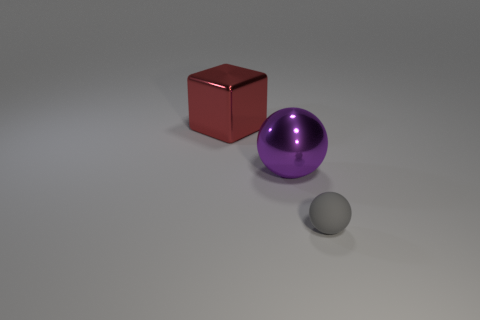Add 3 yellow metal blocks. How many objects exist? 6 Subtract all balls. How many objects are left? 1 Add 1 small gray matte objects. How many small gray matte objects exist? 2 Subtract 1 gray balls. How many objects are left? 2 Subtract all cyan shiny cylinders. Subtract all big purple spheres. How many objects are left? 2 Add 2 gray things. How many gray things are left? 3 